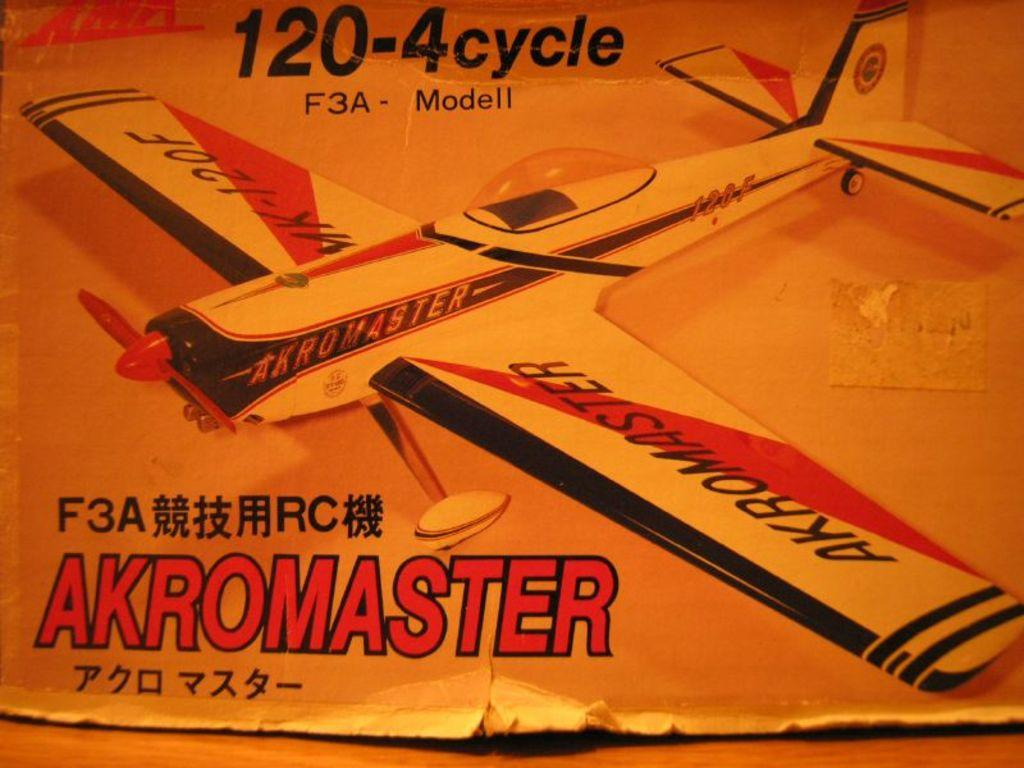<image>
Create a compact narrative representing the image presented. a box for an arkomaster airplane model kit 